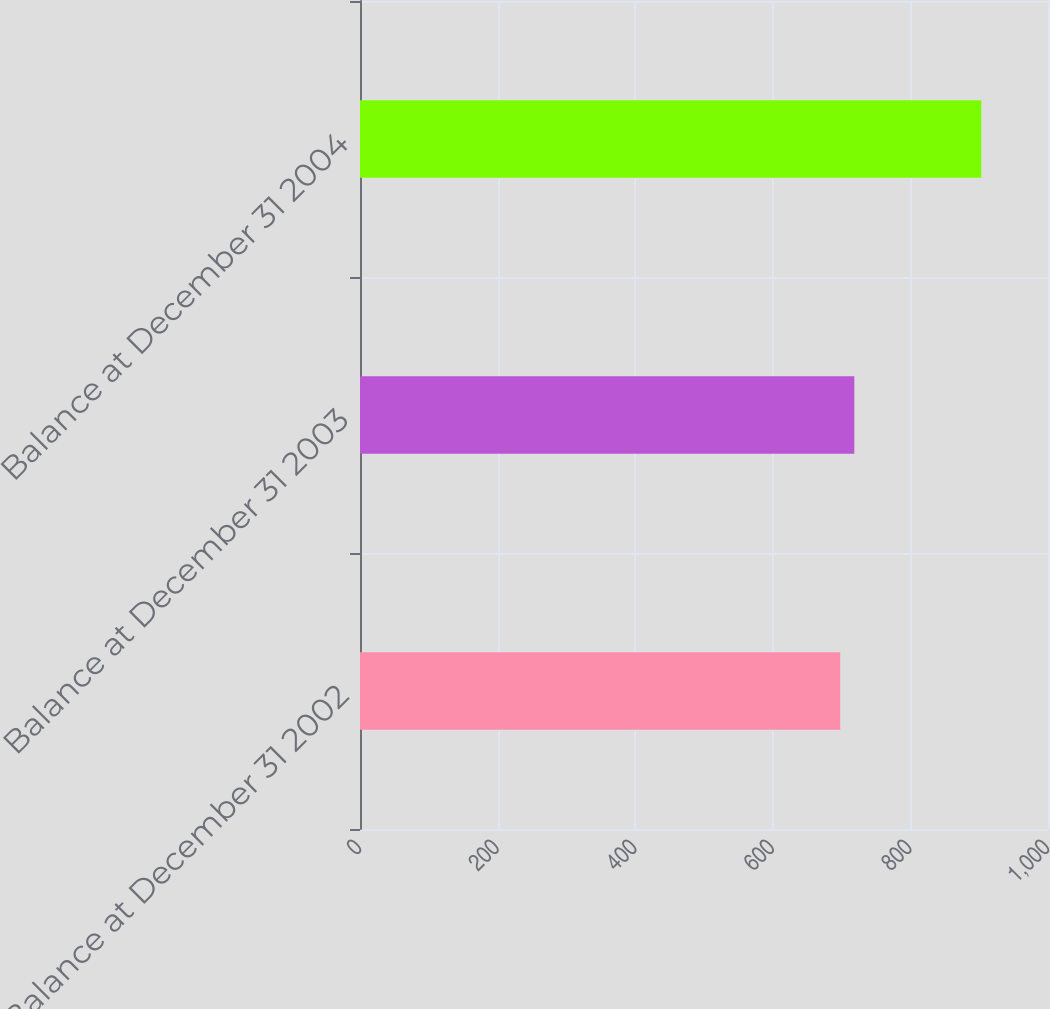Convert chart to OTSL. <chart><loc_0><loc_0><loc_500><loc_500><bar_chart><fcel>Balance at December 31 2002<fcel>Balance at December 31 2003<fcel>Balance at December 31 2004<nl><fcel>698<fcel>718.5<fcel>903<nl></chart> 